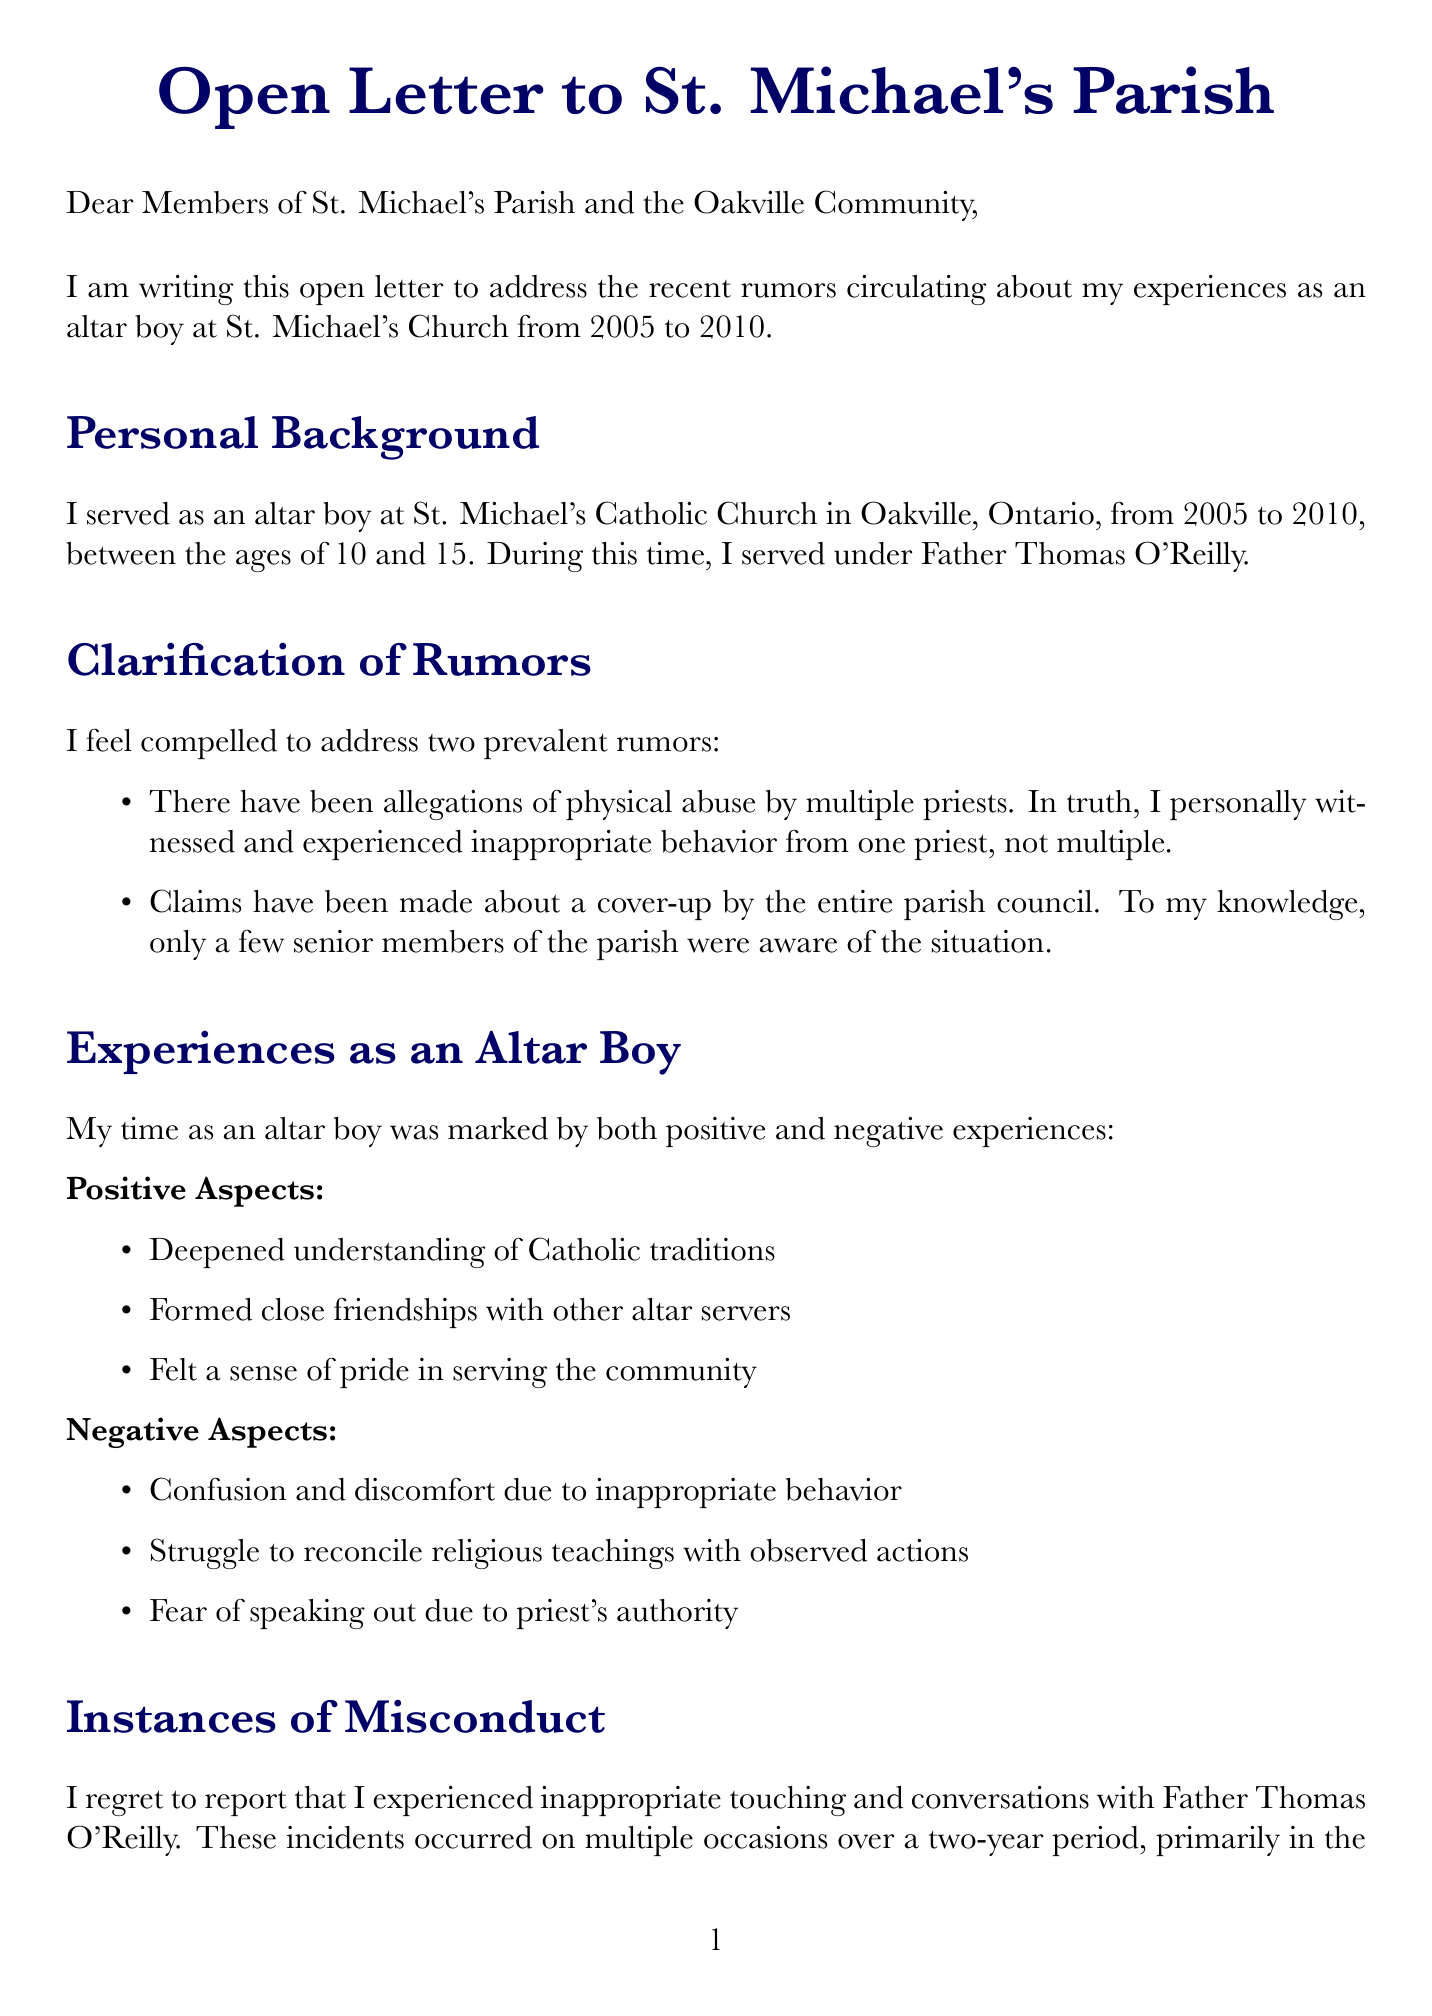What years did the author serve as an altar boy? The author's time serving as an altar boy is stated clearly in the document as from 2005 to 2010.
Answer: 2005-2010 What was the age of the author during their time as an altar boy? The letter indicates that the author was between 10 and 15 years old while serving.
Answer: 10 and 15 Who was the priest mentioned in the letter? The document provides the name of the priest under whom the author served as an altar boy, which is Father Thomas O'Reilly.
Answer: Father Thomas O'Reilly What specific type of misconduct is reported in the letter? The document details the nature of inappropriate behavior as inappropriate touching and conversations.
Answer: Inappropriate touching and conversations How many altar boys witnessed the misconduct? The letter notes that two other altar boys witnessed the inappropriate behavior, though they remain anonymous.
Answer: Two What is one positive aspect of being an altar boy mentioned in the letter? The author lists multiple positive aspects, one of which includes a deepened understanding of Catholic traditions.
Answer: Deepened understanding of Catholic traditions What is the author's ongoing journey described in the impact on faith section? The document reveals that the author is in an ongoing process of healing and redefining their relationship with God.
Answer: Ongoing process of healing and redefining my relationship with God What does the author urge church leadership to do? The author suggests implementing stricter background checks and monitoring of clergy as a necessary action.
Answer: Implement stricter background checks and monitoring of clergy What hotline is provided for support in the letter? The document explicitly includes the Canadian Child Abuse Hotline number for those seeking assistance.
Answer: Canadian Child Abuse Hotline: 1-800-422-4453 